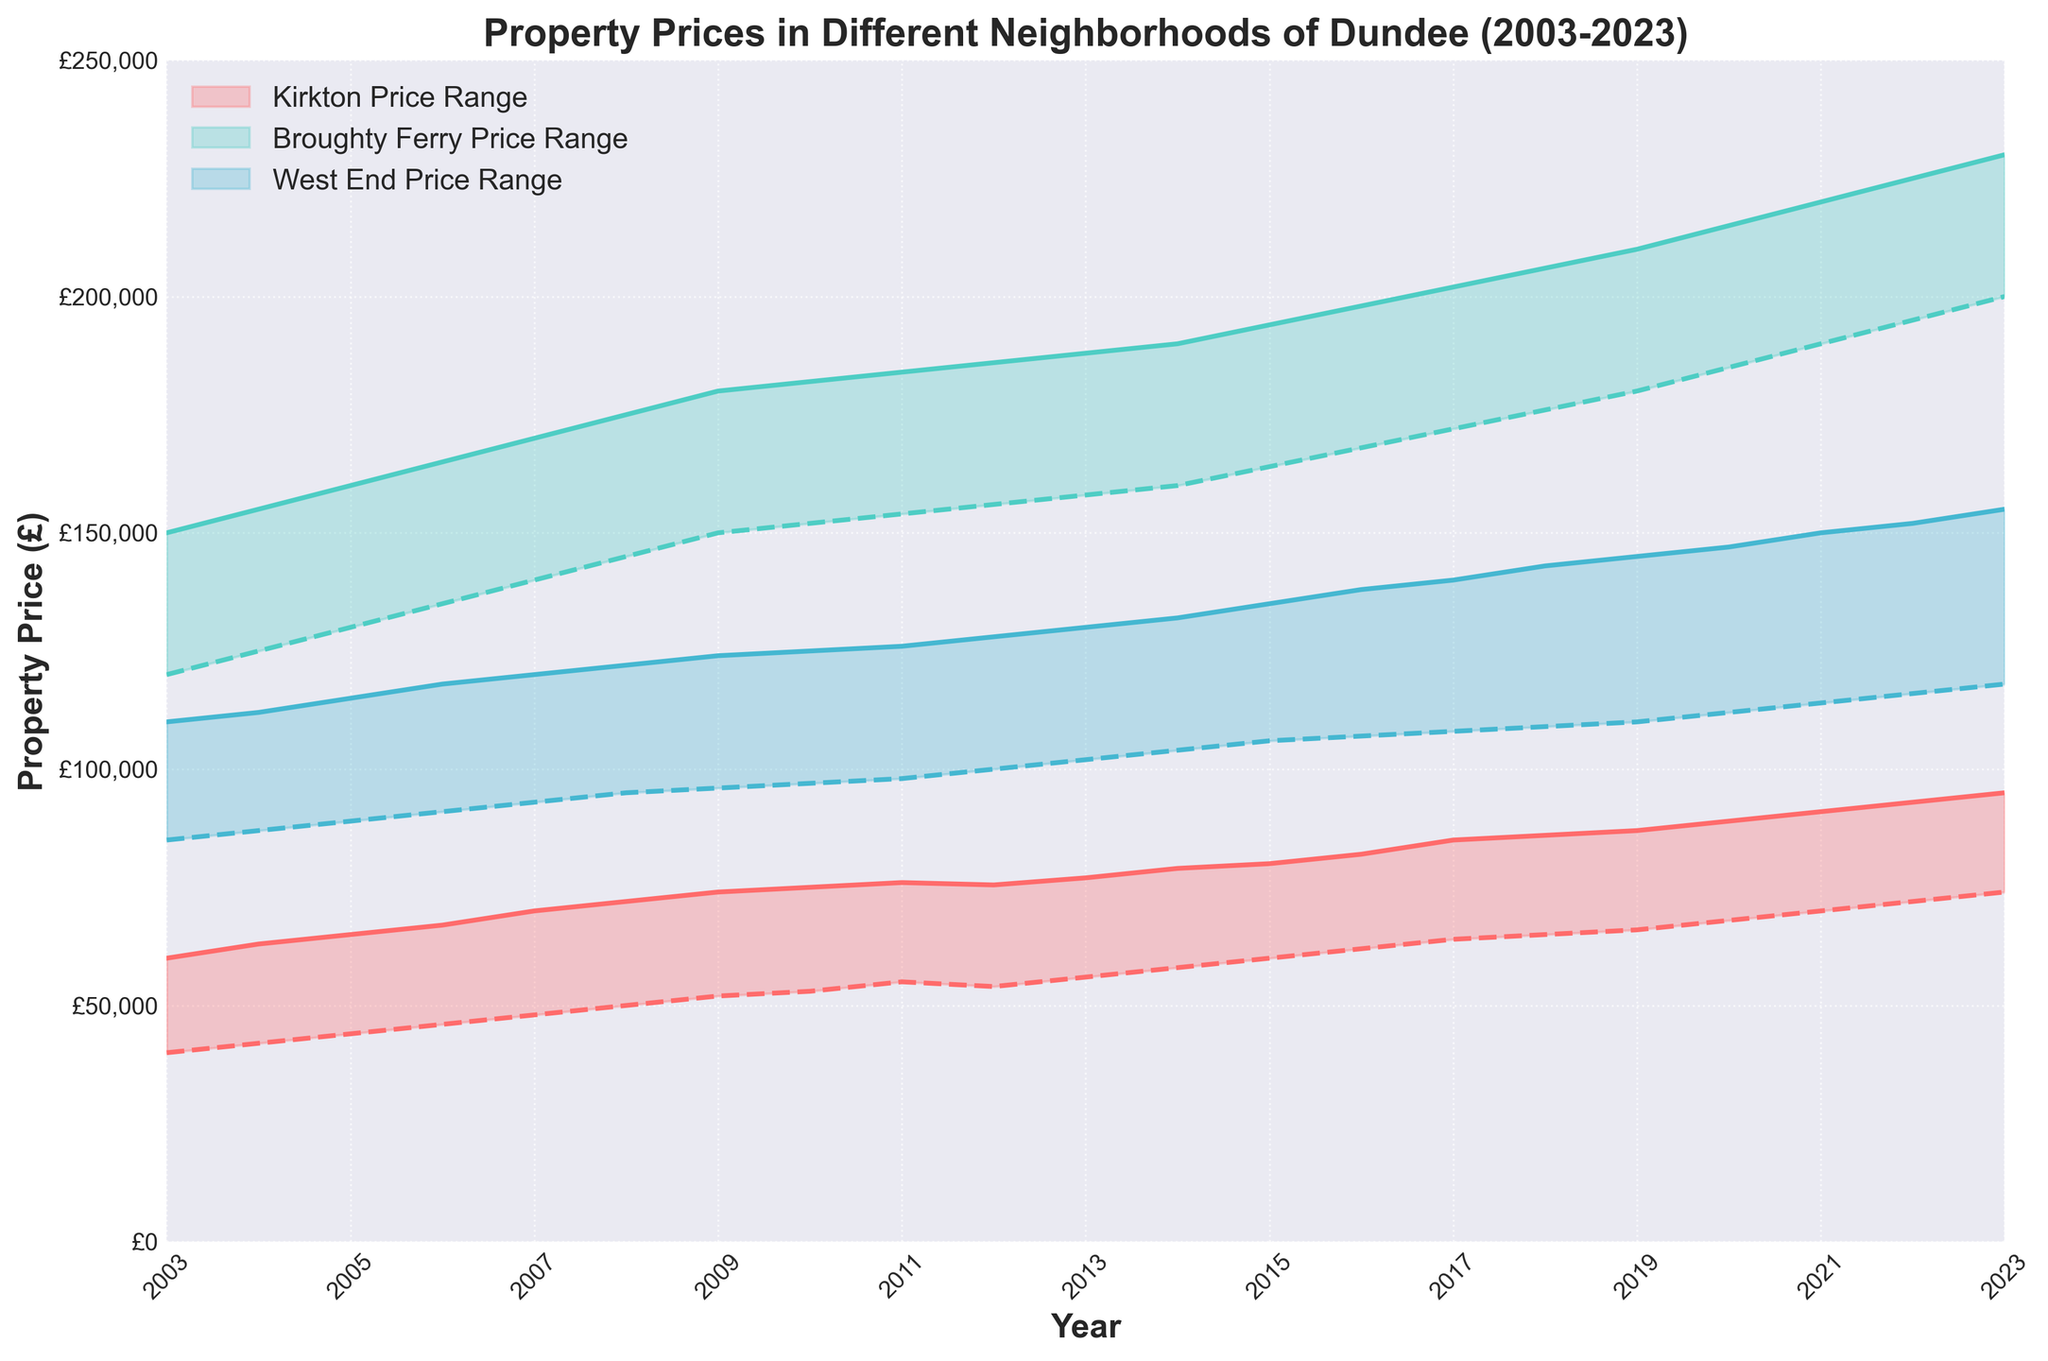What's the title of the chart? The title of the chart is located above the chart and conveys its main subject. Here, it reads "Property Prices in Different Neighborhoods of Dundee (2003-2023)."
Answer: Property Prices in Different Neighborhoods of Dundee (2003-2023) Which neighborhood had the highest maximum property price in 2023? The maximum price range for each year is shown at the top of the shaded area for each neighborhood. In 2023, Broughty Ferry has the highest maximum price of all neighborhoods.
Answer: Broughty Ferry What are the minimum and maximum property prices in Kirkton in 2010? Referring to the shaded area corresponding to Kirkton in 2010, the minimum and maximum property prices can be seen at the edges of the price range.
Answer: £53,000 and £75,000 How does the minimum property price in the West End in 2020 compare to the minimum property price in Kirkton in the same year? Locate 2020 on the x-axis and compare the lower edges of the shaded areas for both neighborhoods. The minimum price in West End is £112,000, while in Kirkton it is £68,000.
Answer: West End's minimum price is higher than Kirkton's What is the difference in maximum property prices between Broughty Ferry and the West End in 2015? Locate 2015 on the x-axis and compare the top edges of the shaded areas for both neighborhoods. The maximum price for Broughty Ferry is £194,000, while for the West End it is £135,000. The difference is £194,000 - £135,000.
Answer: £59,000 Which neighborhood showed the smallest increase in maximum property price from 2003 to 2023? Calculate the increase in each neighborhood's maximum price by subtracting the 2003 value from the 2023 value for each neighborhood. Compare the results.
Answer: West End What trends are observable in property prices in Kirkton over the last 20 years? Look at the property price lines for Kirkton from 2003 to 2023 and observe their direction. Both the minimum and maximum prices show a consistent upward trend throughout the period, indicating a steady increase in property prices.
Answer: Steady increase In which year did Kirkton see the biggest jump in maximum property prices? Focus on Kirkton's maximum price line and look for the steepest upward slope. The sharpest increase in price is observed between 2020 and 2021 where the price jumps from about £89,000 to £91,000.
Answer: 2021 How does the price range in Kirkton compare to the price range in Broughty Ferry in 2023? Compare the height of the shaded areas for both neighborhoods in 2023. Kirkton has a range of £74,000 to £95,000, while Broughty Ferry has a range of £200,000 to £230,000, clearly indicating that Broughty Ferry's range is much higher.
Answer: Broughty Ferry's range is much higher 